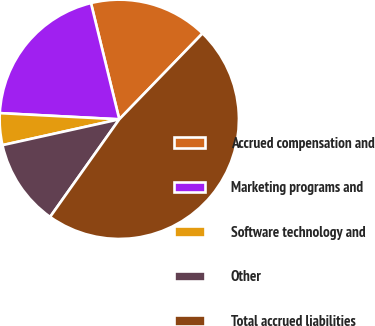Convert chart to OTSL. <chart><loc_0><loc_0><loc_500><loc_500><pie_chart><fcel>Accrued compensation and<fcel>Marketing programs and<fcel>Software technology and<fcel>Other<fcel>Total accrued liabilities<nl><fcel>16.05%<fcel>20.37%<fcel>4.29%<fcel>11.72%<fcel>47.56%<nl></chart> 